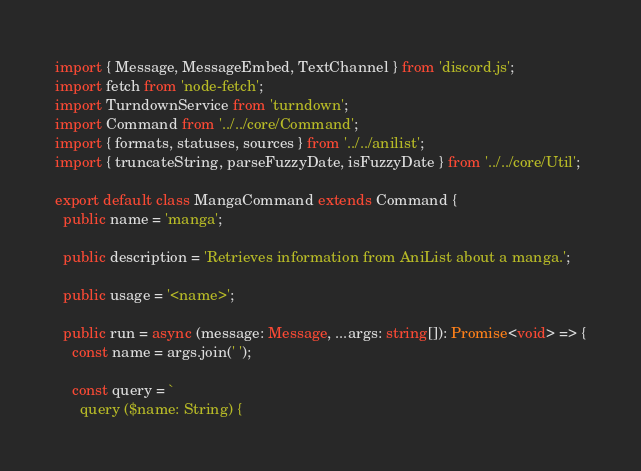Convert code to text. <code><loc_0><loc_0><loc_500><loc_500><_TypeScript_>import { Message, MessageEmbed, TextChannel } from 'discord.js';
import fetch from 'node-fetch';
import TurndownService from 'turndown';
import Command from '../../core/Command';
import { formats, statuses, sources } from '../../anilist';
import { truncateString, parseFuzzyDate, isFuzzyDate } from '../../core/Util';

export default class MangaCommand extends Command {
  public name = 'manga';

  public description = 'Retrieves information from AniList about a manga.';

  public usage = '<name>';

  public run = async (message: Message, ...args: string[]): Promise<void> => {
    const name = args.join(' ');

    const query = `
      query ($name: String) {</code> 